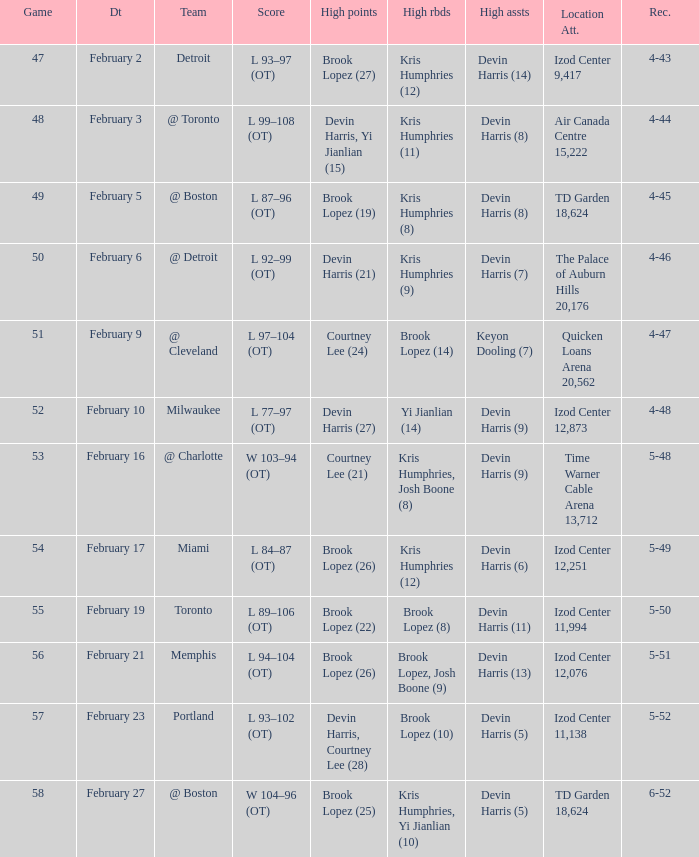What was the score of the game in which Brook Lopez (8) did the high rebounds? L 89–106 (OT). 